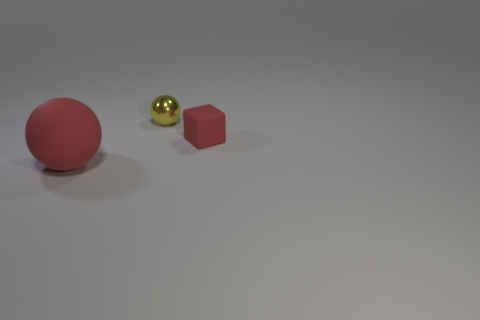What do the colors in this image tell you about its mood or style? The image features a limited color palette with muted tones. The red ball provides a pop of color against the neutral background, which can evoke a sense of minimalism and modernity. The overall mood is tranquil and understated. 